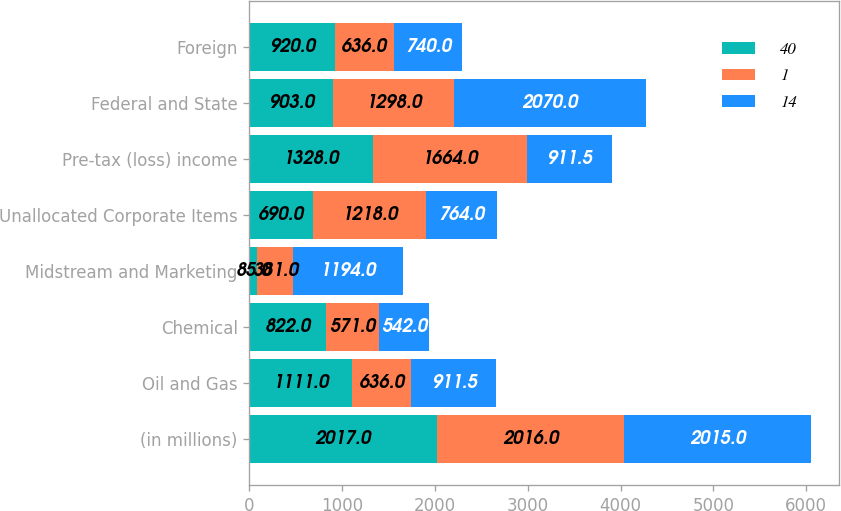Convert chart. <chart><loc_0><loc_0><loc_500><loc_500><stacked_bar_chart><ecel><fcel>(in millions)<fcel>Oil and Gas<fcel>Chemical<fcel>Midstream and Marketing<fcel>Unallocated Corporate Items<fcel>Pre-tax (loss) income<fcel>Federal and State<fcel>Foreign<nl><fcel>40<fcel>2017<fcel>1111<fcel>822<fcel>85<fcel>690<fcel>1328<fcel>903<fcel>920<nl><fcel>1<fcel>2016<fcel>636<fcel>571<fcel>381<fcel>1218<fcel>1664<fcel>1298<fcel>636<nl><fcel>14<fcel>2015<fcel>911.5<fcel>542<fcel>1194<fcel>764<fcel>911.5<fcel>2070<fcel>740<nl></chart> 